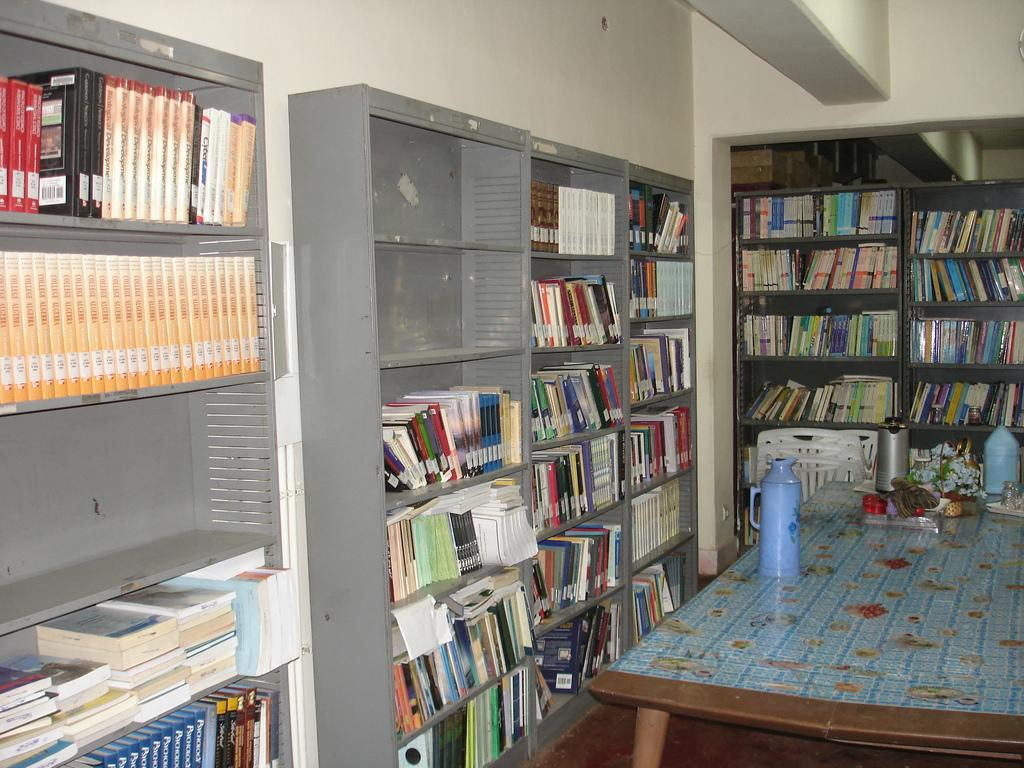What piece of furniture is present in the image? There is a table in the image. What object is placed on the table? There is a bottle on the table. What type of storage unit is visible in the image? There is a rack in the image. What items are stored in the rack? There are books in the rack. Can you tell me how the camera captures the fight between the two characters in the image? There is no camera or fight present in the image; it features a table, a bottle, a rack, and books. What is the taste of the books in the image? Books do not have a taste, as they are not edible items. 